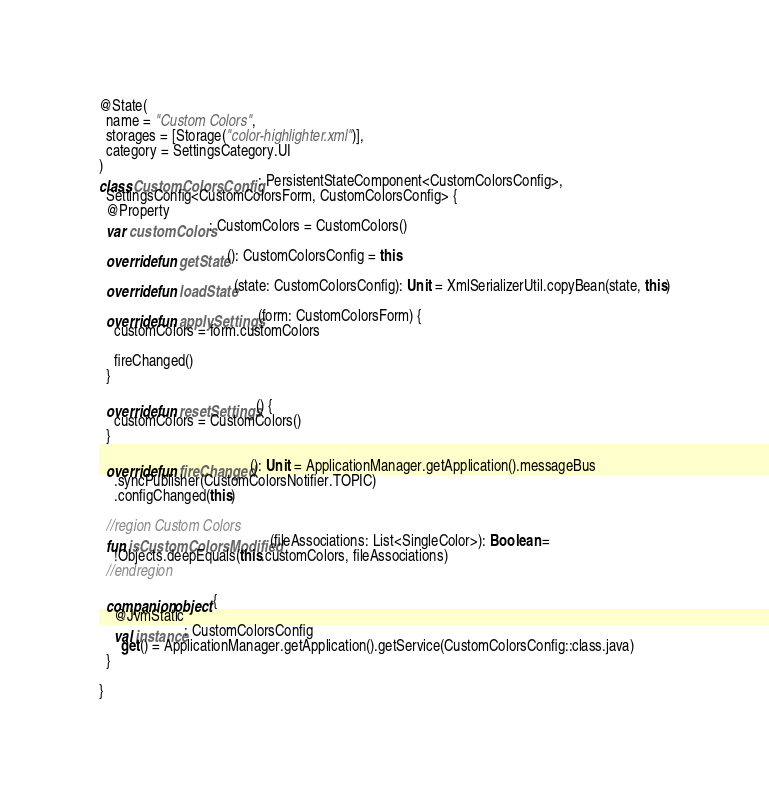Convert code to text. <code><loc_0><loc_0><loc_500><loc_500><_Kotlin_>
@State(
  name = "Custom Colors",
  storages = [Storage("color-highlighter.xml")],
  category = SettingsCategory.UI
)
class CustomColorsConfig : PersistentStateComponent<CustomColorsConfig>,
  SettingsConfig<CustomColorsForm, CustomColorsConfig> {
  @Property
  var customColors: CustomColors = CustomColors()

  override fun getState(): CustomColorsConfig = this

  override fun loadState(state: CustomColorsConfig): Unit = XmlSerializerUtil.copyBean(state, this)

  override fun applySettings(form: CustomColorsForm) {
    customColors = form.customColors

    fireChanged()
  }

  override fun resetSettings() {
    customColors = CustomColors()
  }

  override fun fireChanged(): Unit = ApplicationManager.getApplication().messageBus
    .syncPublisher(CustomColorsNotifier.TOPIC)
    .configChanged(this)

  //region Custom Colors
  fun isCustomColorsModified(fileAssociations: List<SingleColor>): Boolean =
    !Objects.deepEquals(this.customColors, fileAssociations)
  //endregion

  companion object {
    @JvmStatic
    val instance: CustomColorsConfig
      get() = ApplicationManager.getApplication().getService(CustomColorsConfig::class.java)
  }

}
</code> 